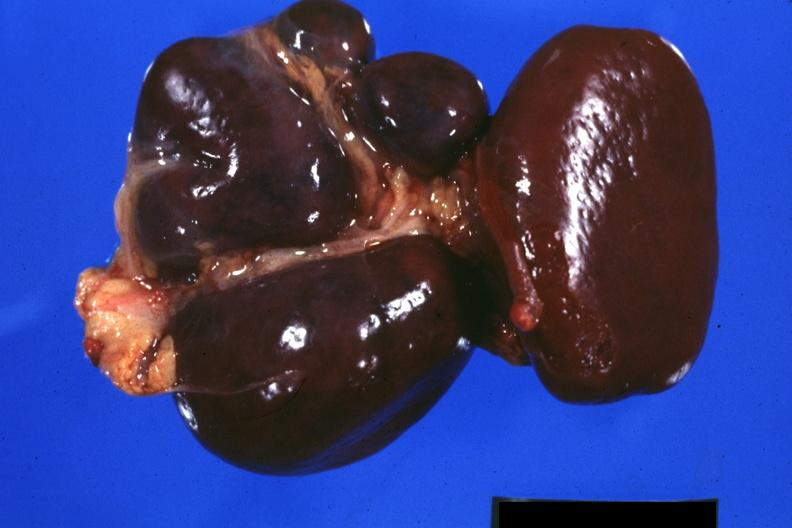what is present?
Answer the question using a single word or phrase. Polysplenia 